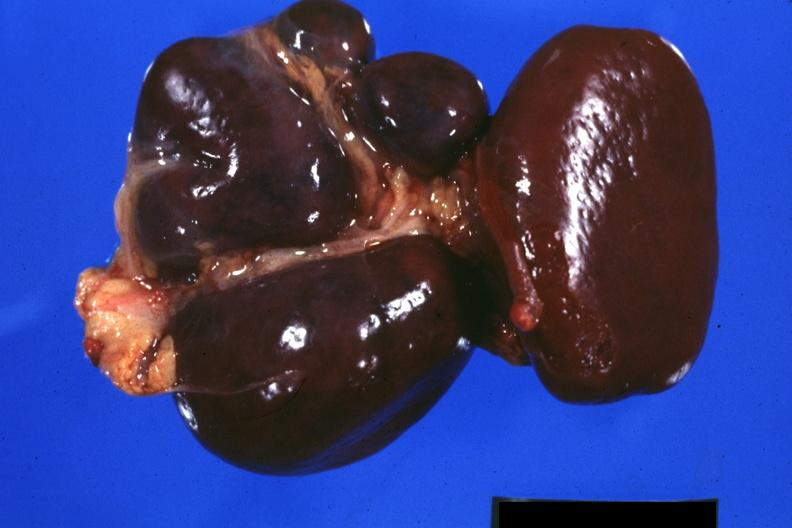what is present?
Answer the question using a single word or phrase. Polysplenia 